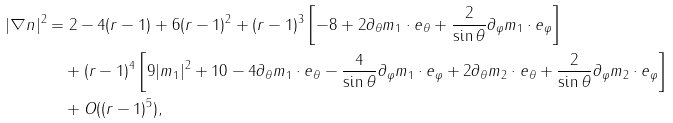<formula> <loc_0><loc_0><loc_500><loc_500>| \nabla n | ^ { 2 } & = 2 - 4 ( r - 1 ) + 6 ( r - 1 ) ^ { 2 } + ( r - 1 ) ^ { 3 } \left [ - 8 + 2 \partial _ { \theta } m _ { 1 } \cdot e _ { \theta } + \frac { 2 } { \sin \theta } \partial _ { \varphi } m _ { 1 } \cdot e _ { \varphi } \right ] \\ & \quad + ( r - 1 ) ^ { 4 } \left [ 9 | m _ { 1 } | ^ { 2 } + 1 0 - 4 \partial _ { \theta } m _ { 1 } \cdot e _ { \theta } - \frac { 4 } { \sin \theta } \partial _ { \varphi } m _ { 1 } \cdot e _ { \varphi } + 2 \partial _ { \theta } m _ { 2 } \cdot e _ { \theta } + \frac { 2 } { \sin \theta } \partial _ { \varphi } m _ { 2 } \cdot e _ { \varphi } \right ] \\ & \quad + O ( ( r - 1 ) ^ { 5 } ) ,</formula> 